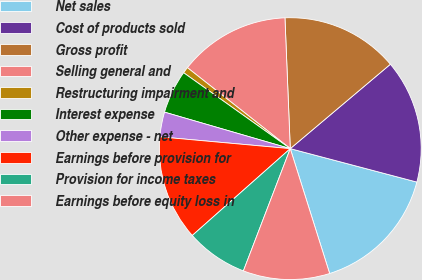Convert chart. <chart><loc_0><loc_0><loc_500><loc_500><pie_chart><fcel>Net sales<fcel>Cost of products sold<fcel>Gross profit<fcel>Selling general and<fcel>Restructuring impairment and<fcel>Interest expense<fcel>Other expense - net<fcel>Earnings before provision for<fcel>Provision for income taxes<fcel>Earnings before equity loss in<nl><fcel>16.03%<fcel>15.26%<fcel>14.5%<fcel>13.74%<fcel>0.77%<fcel>5.35%<fcel>3.06%<fcel>12.98%<fcel>7.63%<fcel>10.69%<nl></chart> 